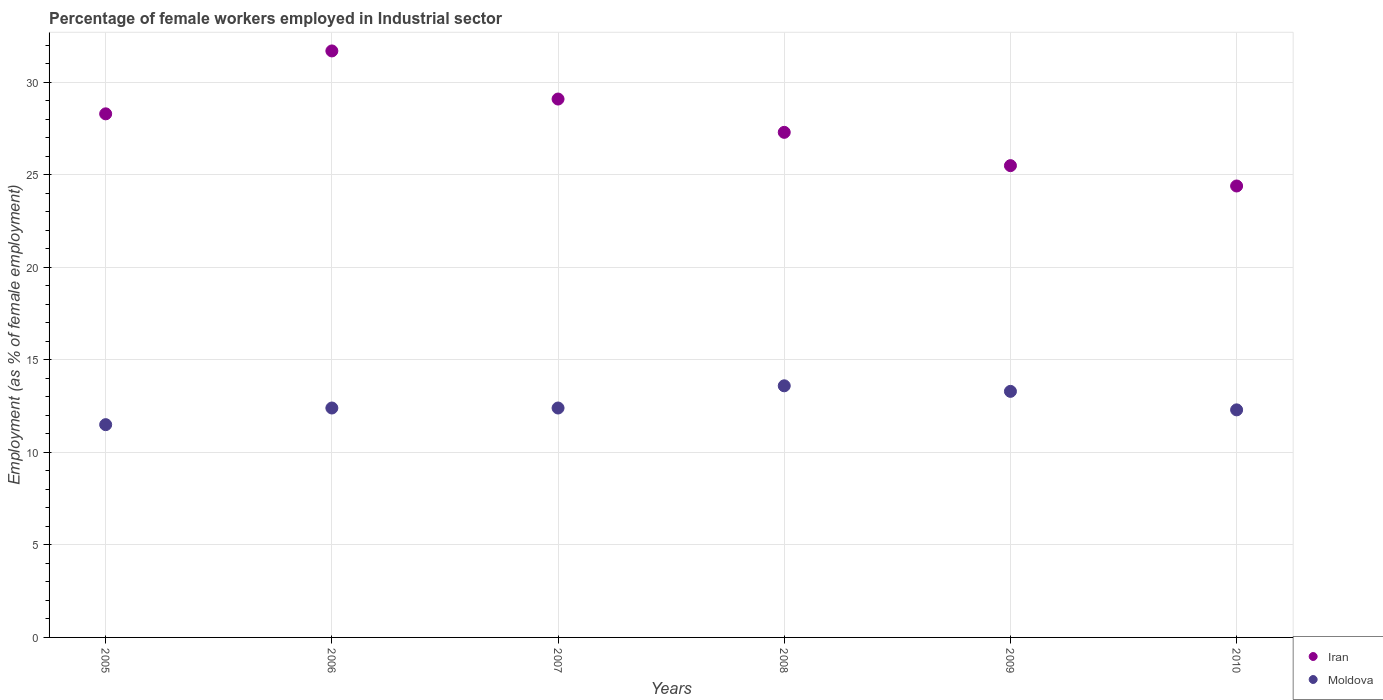What is the percentage of females employed in Industrial sector in Iran in 2005?
Provide a short and direct response. 28.3. Across all years, what is the maximum percentage of females employed in Industrial sector in Moldova?
Keep it short and to the point. 13.6. Across all years, what is the minimum percentage of females employed in Industrial sector in Iran?
Offer a very short reply. 24.4. In which year was the percentage of females employed in Industrial sector in Iran maximum?
Give a very brief answer. 2006. What is the total percentage of females employed in Industrial sector in Moldova in the graph?
Give a very brief answer. 75.5. What is the difference between the percentage of females employed in Industrial sector in Iran in 2007 and that in 2010?
Offer a terse response. 4.7. What is the difference between the percentage of females employed in Industrial sector in Iran in 2009 and the percentage of females employed in Industrial sector in Moldova in 2008?
Your response must be concise. 11.9. What is the average percentage of females employed in Industrial sector in Iran per year?
Offer a very short reply. 27.72. In the year 2009, what is the difference between the percentage of females employed in Industrial sector in Iran and percentage of females employed in Industrial sector in Moldova?
Give a very brief answer. 12.2. In how many years, is the percentage of females employed in Industrial sector in Iran greater than 1 %?
Provide a succinct answer. 6. What is the ratio of the percentage of females employed in Industrial sector in Moldova in 2009 to that in 2010?
Your answer should be compact. 1.08. Is the percentage of females employed in Industrial sector in Iran in 2005 less than that in 2006?
Offer a very short reply. Yes. Is the difference between the percentage of females employed in Industrial sector in Iran in 2007 and 2008 greater than the difference between the percentage of females employed in Industrial sector in Moldova in 2007 and 2008?
Give a very brief answer. Yes. What is the difference between the highest and the second highest percentage of females employed in Industrial sector in Moldova?
Provide a short and direct response. 0.3. What is the difference between the highest and the lowest percentage of females employed in Industrial sector in Moldova?
Your answer should be very brief. 2.1. Is the percentage of females employed in Industrial sector in Moldova strictly less than the percentage of females employed in Industrial sector in Iran over the years?
Your answer should be very brief. Yes. How many dotlines are there?
Make the answer very short. 2. How many years are there in the graph?
Your answer should be very brief. 6. Does the graph contain grids?
Provide a succinct answer. Yes. Where does the legend appear in the graph?
Keep it short and to the point. Bottom right. How many legend labels are there?
Your response must be concise. 2. What is the title of the graph?
Make the answer very short. Percentage of female workers employed in Industrial sector. What is the label or title of the X-axis?
Provide a short and direct response. Years. What is the label or title of the Y-axis?
Your answer should be compact. Employment (as % of female employment). What is the Employment (as % of female employment) in Iran in 2005?
Your answer should be very brief. 28.3. What is the Employment (as % of female employment) of Iran in 2006?
Provide a succinct answer. 31.7. What is the Employment (as % of female employment) of Moldova in 2006?
Your answer should be compact. 12.4. What is the Employment (as % of female employment) in Iran in 2007?
Keep it short and to the point. 29.1. What is the Employment (as % of female employment) in Moldova in 2007?
Offer a very short reply. 12.4. What is the Employment (as % of female employment) of Iran in 2008?
Provide a succinct answer. 27.3. What is the Employment (as % of female employment) of Moldova in 2008?
Provide a short and direct response. 13.6. What is the Employment (as % of female employment) of Iran in 2009?
Your response must be concise. 25.5. What is the Employment (as % of female employment) of Moldova in 2009?
Offer a terse response. 13.3. What is the Employment (as % of female employment) in Iran in 2010?
Make the answer very short. 24.4. What is the Employment (as % of female employment) in Moldova in 2010?
Ensure brevity in your answer.  12.3. Across all years, what is the maximum Employment (as % of female employment) of Iran?
Keep it short and to the point. 31.7. Across all years, what is the maximum Employment (as % of female employment) of Moldova?
Your answer should be very brief. 13.6. Across all years, what is the minimum Employment (as % of female employment) of Iran?
Offer a very short reply. 24.4. What is the total Employment (as % of female employment) in Iran in the graph?
Provide a succinct answer. 166.3. What is the total Employment (as % of female employment) of Moldova in the graph?
Your answer should be very brief. 75.5. What is the difference between the Employment (as % of female employment) of Moldova in 2005 and that in 2006?
Give a very brief answer. -0.9. What is the difference between the Employment (as % of female employment) of Moldova in 2005 and that in 2007?
Provide a succinct answer. -0.9. What is the difference between the Employment (as % of female employment) of Iran in 2005 and that in 2009?
Offer a very short reply. 2.8. What is the difference between the Employment (as % of female employment) in Moldova in 2005 and that in 2009?
Offer a terse response. -1.8. What is the difference between the Employment (as % of female employment) in Moldova in 2006 and that in 2007?
Give a very brief answer. 0. What is the difference between the Employment (as % of female employment) of Iran in 2006 and that in 2008?
Your answer should be compact. 4.4. What is the difference between the Employment (as % of female employment) in Moldova in 2006 and that in 2008?
Make the answer very short. -1.2. What is the difference between the Employment (as % of female employment) in Iran in 2006 and that in 2009?
Make the answer very short. 6.2. What is the difference between the Employment (as % of female employment) in Moldova in 2006 and that in 2010?
Give a very brief answer. 0.1. What is the difference between the Employment (as % of female employment) of Iran in 2007 and that in 2008?
Offer a very short reply. 1.8. What is the difference between the Employment (as % of female employment) of Moldova in 2007 and that in 2008?
Your answer should be compact. -1.2. What is the difference between the Employment (as % of female employment) of Iran in 2007 and that in 2009?
Your answer should be compact. 3.6. What is the difference between the Employment (as % of female employment) of Iran in 2008 and that in 2009?
Offer a very short reply. 1.8. What is the difference between the Employment (as % of female employment) of Moldova in 2008 and that in 2009?
Your response must be concise. 0.3. What is the difference between the Employment (as % of female employment) in Moldova in 2008 and that in 2010?
Your response must be concise. 1.3. What is the difference between the Employment (as % of female employment) in Iran in 2009 and that in 2010?
Your answer should be very brief. 1.1. What is the difference between the Employment (as % of female employment) of Iran in 2005 and the Employment (as % of female employment) of Moldova in 2006?
Your answer should be very brief. 15.9. What is the difference between the Employment (as % of female employment) of Iran in 2005 and the Employment (as % of female employment) of Moldova in 2007?
Provide a short and direct response. 15.9. What is the difference between the Employment (as % of female employment) of Iran in 2005 and the Employment (as % of female employment) of Moldova in 2008?
Make the answer very short. 14.7. What is the difference between the Employment (as % of female employment) in Iran in 2005 and the Employment (as % of female employment) in Moldova in 2010?
Provide a succinct answer. 16. What is the difference between the Employment (as % of female employment) of Iran in 2006 and the Employment (as % of female employment) of Moldova in 2007?
Your response must be concise. 19.3. What is the difference between the Employment (as % of female employment) of Iran in 2006 and the Employment (as % of female employment) of Moldova in 2009?
Offer a terse response. 18.4. What is the difference between the Employment (as % of female employment) of Iran in 2007 and the Employment (as % of female employment) of Moldova in 2008?
Your answer should be compact. 15.5. What is the difference between the Employment (as % of female employment) of Iran in 2007 and the Employment (as % of female employment) of Moldova in 2009?
Make the answer very short. 15.8. What is the difference between the Employment (as % of female employment) of Iran in 2007 and the Employment (as % of female employment) of Moldova in 2010?
Offer a very short reply. 16.8. What is the difference between the Employment (as % of female employment) of Iran in 2008 and the Employment (as % of female employment) of Moldova in 2009?
Offer a terse response. 14. What is the difference between the Employment (as % of female employment) in Iran in 2009 and the Employment (as % of female employment) in Moldova in 2010?
Your response must be concise. 13.2. What is the average Employment (as % of female employment) in Iran per year?
Offer a terse response. 27.72. What is the average Employment (as % of female employment) of Moldova per year?
Your answer should be very brief. 12.58. In the year 2006, what is the difference between the Employment (as % of female employment) in Iran and Employment (as % of female employment) in Moldova?
Ensure brevity in your answer.  19.3. In the year 2008, what is the difference between the Employment (as % of female employment) in Iran and Employment (as % of female employment) in Moldova?
Ensure brevity in your answer.  13.7. What is the ratio of the Employment (as % of female employment) in Iran in 2005 to that in 2006?
Your answer should be very brief. 0.89. What is the ratio of the Employment (as % of female employment) of Moldova in 2005 to that in 2006?
Your response must be concise. 0.93. What is the ratio of the Employment (as % of female employment) in Iran in 2005 to that in 2007?
Offer a terse response. 0.97. What is the ratio of the Employment (as % of female employment) in Moldova in 2005 to that in 2007?
Your answer should be very brief. 0.93. What is the ratio of the Employment (as % of female employment) in Iran in 2005 to that in 2008?
Offer a very short reply. 1.04. What is the ratio of the Employment (as % of female employment) of Moldova in 2005 to that in 2008?
Make the answer very short. 0.85. What is the ratio of the Employment (as % of female employment) of Iran in 2005 to that in 2009?
Provide a succinct answer. 1.11. What is the ratio of the Employment (as % of female employment) in Moldova in 2005 to that in 2009?
Give a very brief answer. 0.86. What is the ratio of the Employment (as % of female employment) of Iran in 2005 to that in 2010?
Give a very brief answer. 1.16. What is the ratio of the Employment (as % of female employment) of Moldova in 2005 to that in 2010?
Provide a short and direct response. 0.94. What is the ratio of the Employment (as % of female employment) in Iran in 2006 to that in 2007?
Offer a terse response. 1.09. What is the ratio of the Employment (as % of female employment) of Iran in 2006 to that in 2008?
Offer a very short reply. 1.16. What is the ratio of the Employment (as % of female employment) of Moldova in 2006 to that in 2008?
Offer a very short reply. 0.91. What is the ratio of the Employment (as % of female employment) in Iran in 2006 to that in 2009?
Offer a terse response. 1.24. What is the ratio of the Employment (as % of female employment) in Moldova in 2006 to that in 2009?
Your answer should be compact. 0.93. What is the ratio of the Employment (as % of female employment) in Iran in 2006 to that in 2010?
Your answer should be very brief. 1.3. What is the ratio of the Employment (as % of female employment) of Iran in 2007 to that in 2008?
Provide a succinct answer. 1.07. What is the ratio of the Employment (as % of female employment) of Moldova in 2007 to that in 2008?
Your answer should be compact. 0.91. What is the ratio of the Employment (as % of female employment) in Iran in 2007 to that in 2009?
Provide a succinct answer. 1.14. What is the ratio of the Employment (as % of female employment) in Moldova in 2007 to that in 2009?
Your answer should be compact. 0.93. What is the ratio of the Employment (as % of female employment) of Iran in 2007 to that in 2010?
Keep it short and to the point. 1.19. What is the ratio of the Employment (as % of female employment) of Iran in 2008 to that in 2009?
Offer a very short reply. 1.07. What is the ratio of the Employment (as % of female employment) in Moldova in 2008 to that in 2009?
Your answer should be very brief. 1.02. What is the ratio of the Employment (as % of female employment) in Iran in 2008 to that in 2010?
Provide a short and direct response. 1.12. What is the ratio of the Employment (as % of female employment) in Moldova in 2008 to that in 2010?
Give a very brief answer. 1.11. What is the ratio of the Employment (as % of female employment) of Iran in 2009 to that in 2010?
Ensure brevity in your answer.  1.05. What is the ratio of the Employment (as % of female employment) in Moldova in 2009 to that in 2010?
Offer a terse response. 1.08. What is the difference between the highest and the second highest Employment (as % of female employment) of Iran?
Your answer should be compact. 2.6. What is the difference between the highest and the second highest Employment (as % of female employment) in Moldova?
Offer a terse response. 0.3. What is the difference between the highest and the lowest Employment (as % of female employment) of Moldova?
Provide a short and direct response. 2.1. 